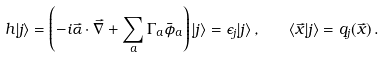<formula> <loc_0><loc_0><loc_500><loc_500>h | j \rangle = \left ( - i { \vec { \alpha } \cdot \vec { \nabla } } + \sum _ { a } \Gamma _ { a } \bar { \phi } _ { a } \right ) | j \rangle = \epsilon _ { j } | j \rangle \, , \quad \langle \vec { x } | j \rangle = q _ { j } ( \vec { x } ) \, .</formula> 